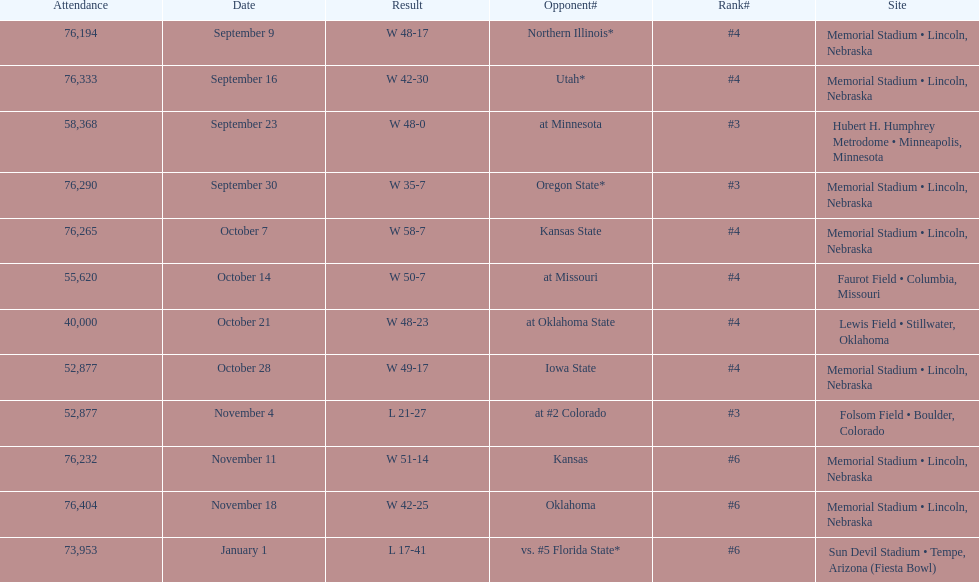How many individuals were present at the oregon state game? 76,290. 